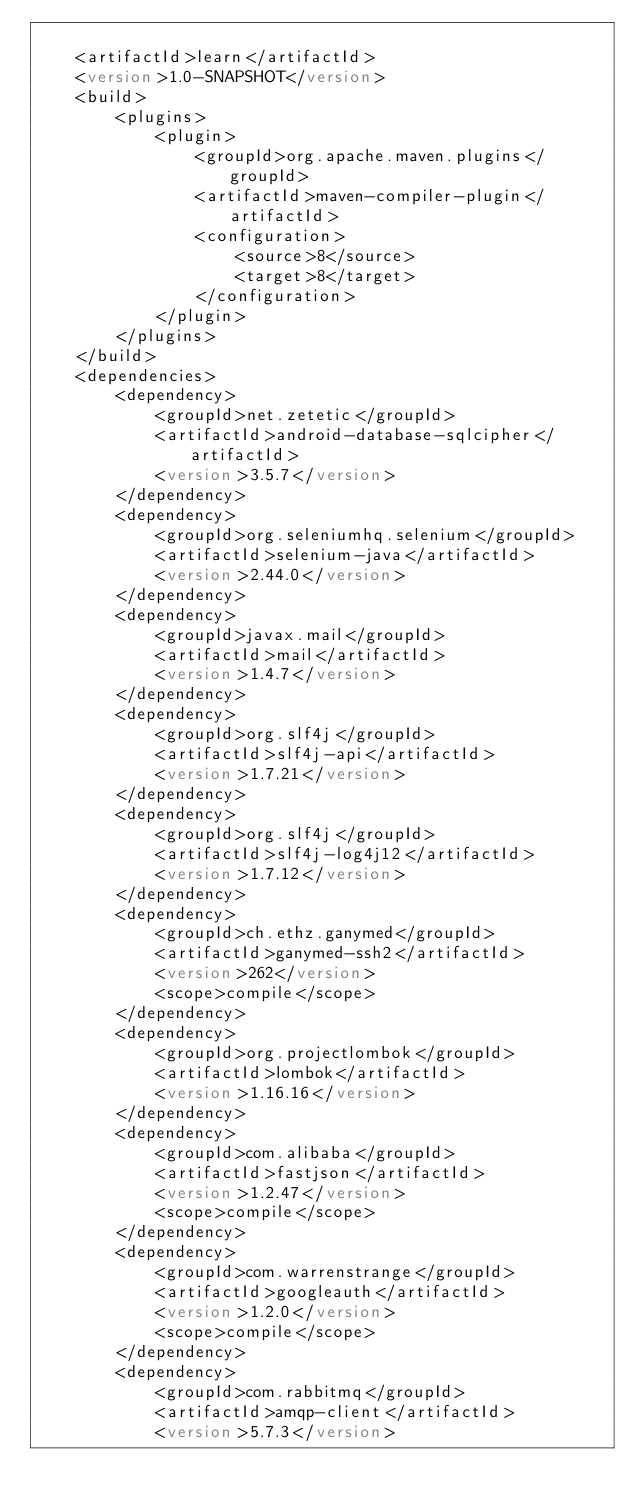<code> <loc_0><loc_0><loc_500><loc_500><_XML_>
    <artifactId>learn</artifactId>
    <version>1.0-SNAPSHOT</version>
    <build>
        <plugins>
            <plugin>
                <groupId>org.apache.maven.plugins</groupId>
                <artifactId>maven-compiler-plugin</artifactId>
                <configuration>
                    <source>8</source>
                    <target>8</target>
                </configuration>
            </plugin>
        </plugins>
    </build>
    <dependencies>
        <dependency>
            <groupId>net.zetetic</groupId>
            <artifactId>android-database-sqlcipher</artifactId>
            <version>3.5.7</version>
        </dependency>
        <dependency>
            <groupId>org.seleniumhq.selenium</groupId>
            <artifactId>selenium-java</artifactId>
            <version>2.44.0</version>
        </dependency>
        <dependency>
            <groupId>javax.mail</groupId>
            <artifactId>mail</artifactId>
            <version>1.4.7</version>
        </dependency>
        <dependency>
            <groupId>org.slf4j</groupId>
            <artifactId>slf4j-api</artifactId>
            <version>1.7.21</version>
        </dependency>
        <dependency>
            <groupId>org.slf4j</groupId>
            <artifactId>slf4j-log4j12</artifactId>
            <version>1.7.12</version>
        </dependency>
        <dependency>
            <groupId>ch.ethz.ganymed</groupId>
            <artifactId>ganymed-ssh2</artifactId>
            <version>262</version>
            <scope>compile</scope>
        </dependency>
        <dependency>
            <groupId>org.projectlombok</groupId>
            <artifactId>lombok</artifactId>
            <version>1.16.16</version>
        </dependency>
        <dependency>
            <groupId>com.alibaba</groupId>
            <artifactId>fastjson</artifactId>
            <version>1.2.47</version>
            <scope>compile</scope>
        </dependency>
        <dependency>
            <groupId>com.warrenstrange</groupId>
            <artifactId>googleauth</artifactId>
            <version>1.2.0</version>
            <scope>compile</scope>
        </dependency>
        <dependency>
            <groupId>com.rabbitmq</groupId>
            <artifactId>amqp-client</artifactId>
            <version>5.7.3</version></code> 